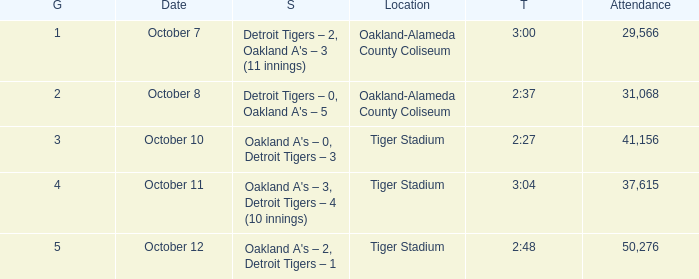What is the number of people in attendance at Oakland-Alameda County Coliseum, and game is 2? 31068.0. 